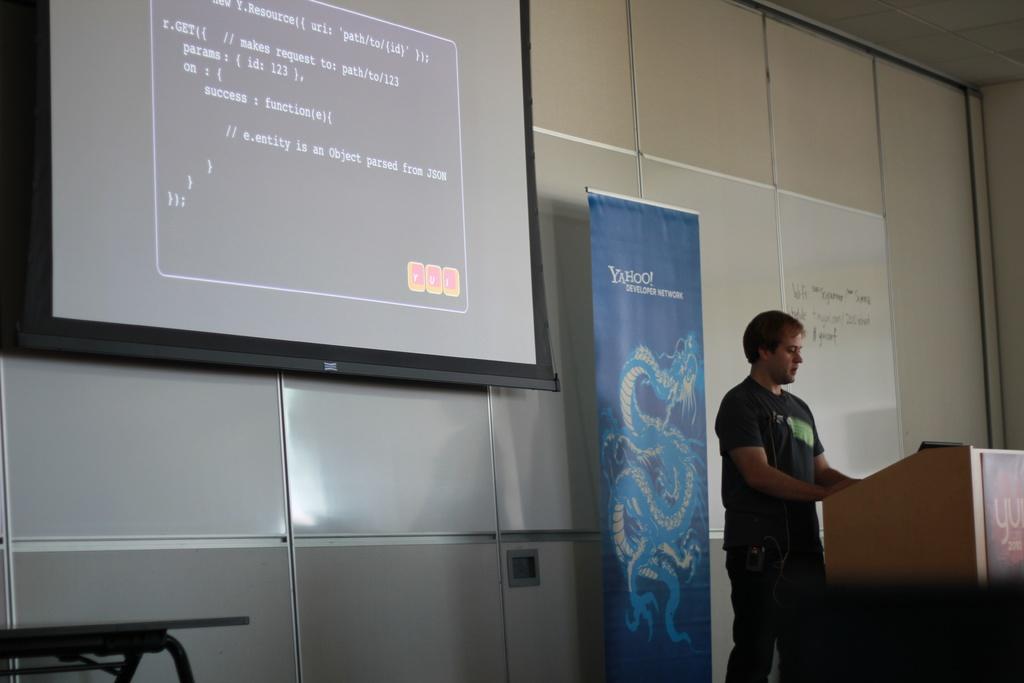What is e.entity?
Ensure brevity in your answer.  Object parsed from json. 